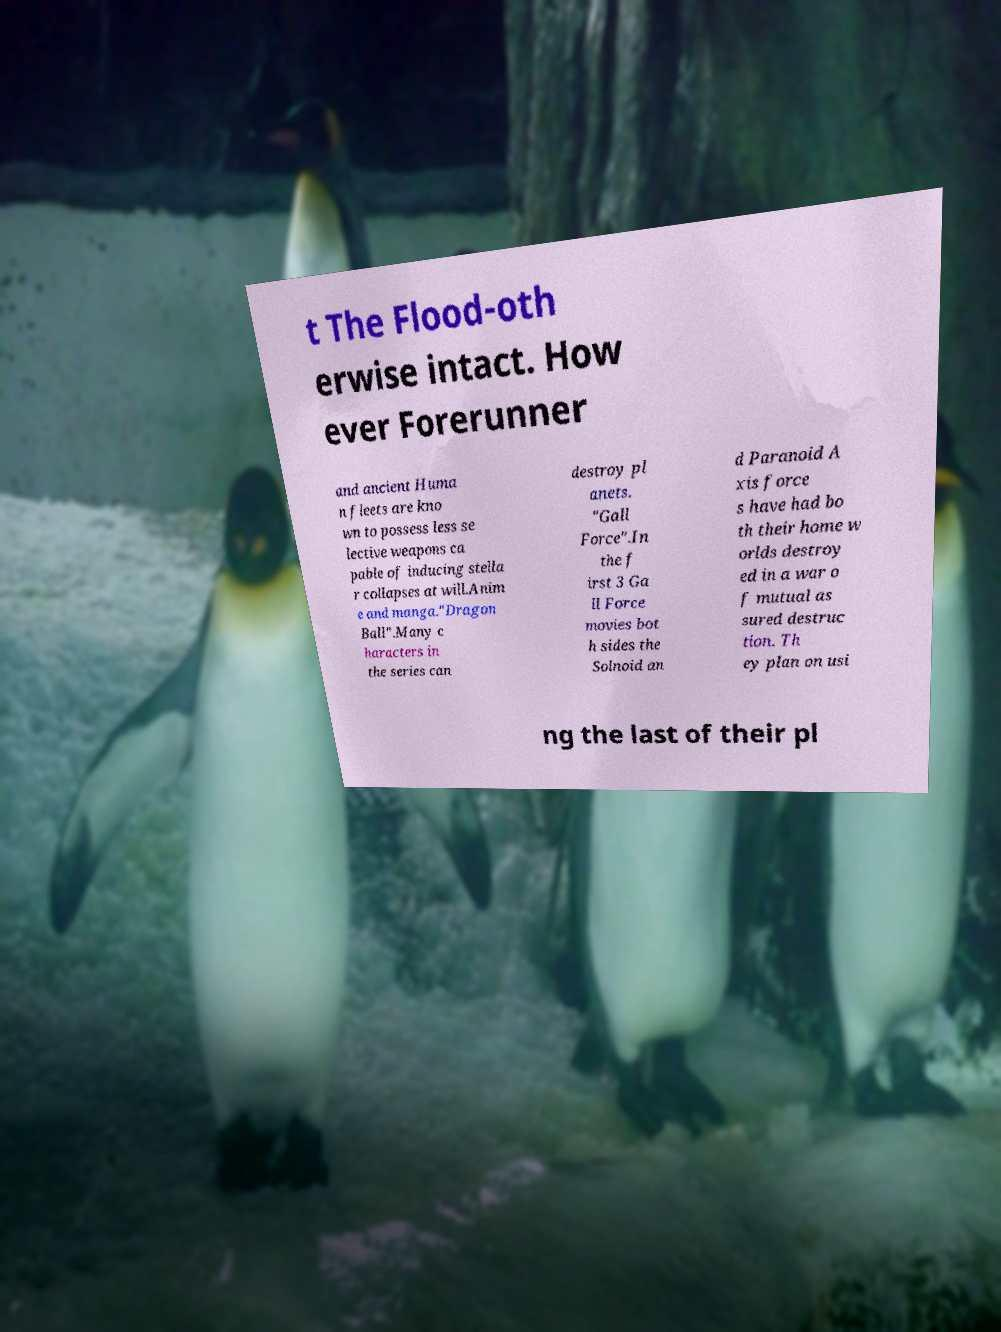Can you read and provide the text displayed in the image?This photo seems to have some interesting text. Can you extract and type it out for me? t The Flood-oth erwise intact. How ever Forerunner and ancient Huma n fleets are kno wn to possess less se lective weapons ca pable of inducing stella r collapses at will.Anim e and manga."Dragon Ball".Many c haracters in the series can destroy pl anets. "Gall Force".In the f irst 3 Ga ll Force movies bot h sides the Solnoid an d Paranoid A xis force s have had bo th their home w orlds destroy ed in a war o f mutual as sured destruc tion. Th ey plan on usi ng the last of their pl 